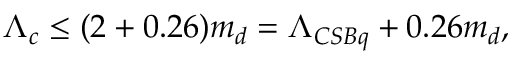<formula> <loc_0><loc_0><loc_500><loc_500>\Lambda _ { c } \leq ( 2 + 0 . 2 6 ) m _ { d } = \Lambda _ { C S B q } + 0 . 2 6 m _ { d } ,</formula> 